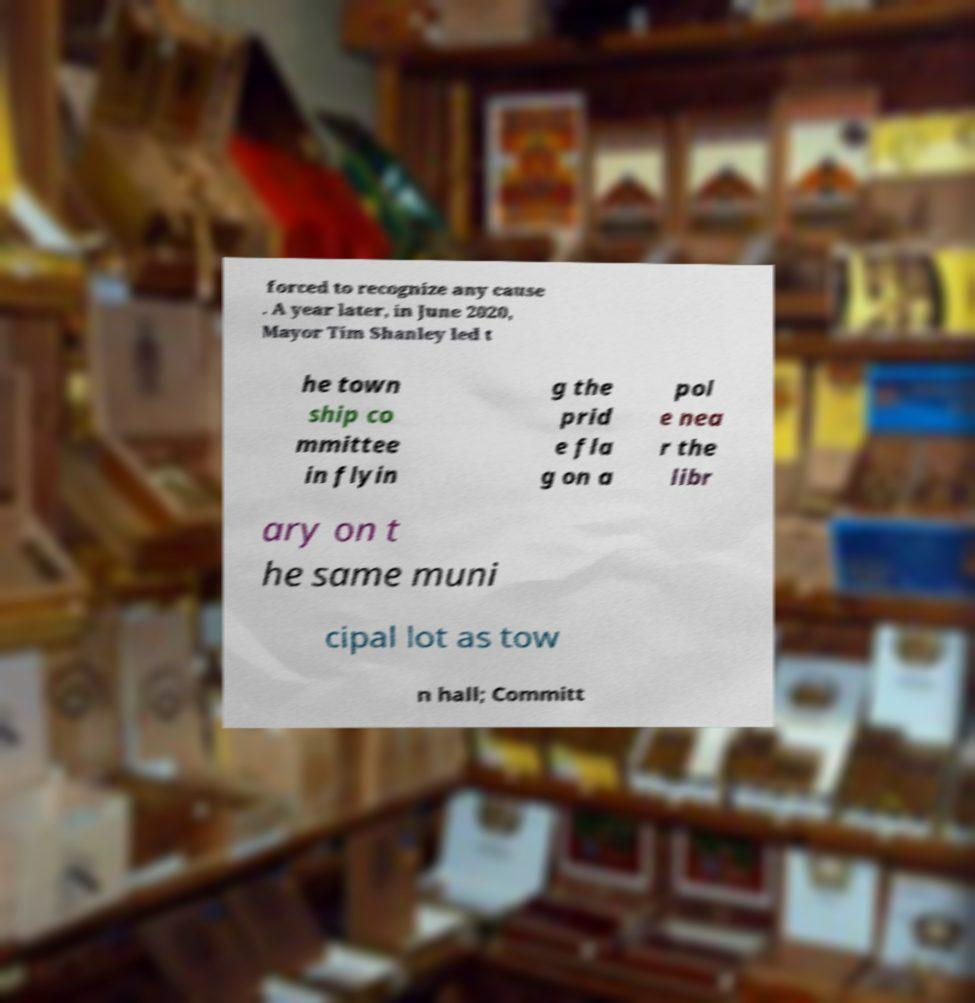Please identify and transcribe the text found in this image. forced to recognize any cause . A year later, in June 2020, Mayor Tim Shanley led t he town ship co mmittee in flyin g the prid e fla g on a pol e nea r the libr ary on t he same muni cipal lot as tow n hall; Committ 